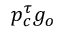<formula> <loc_0><loc_0><loc_500><loc_500>p _ { c } ^ { \tau } g _ { o }</formula> 